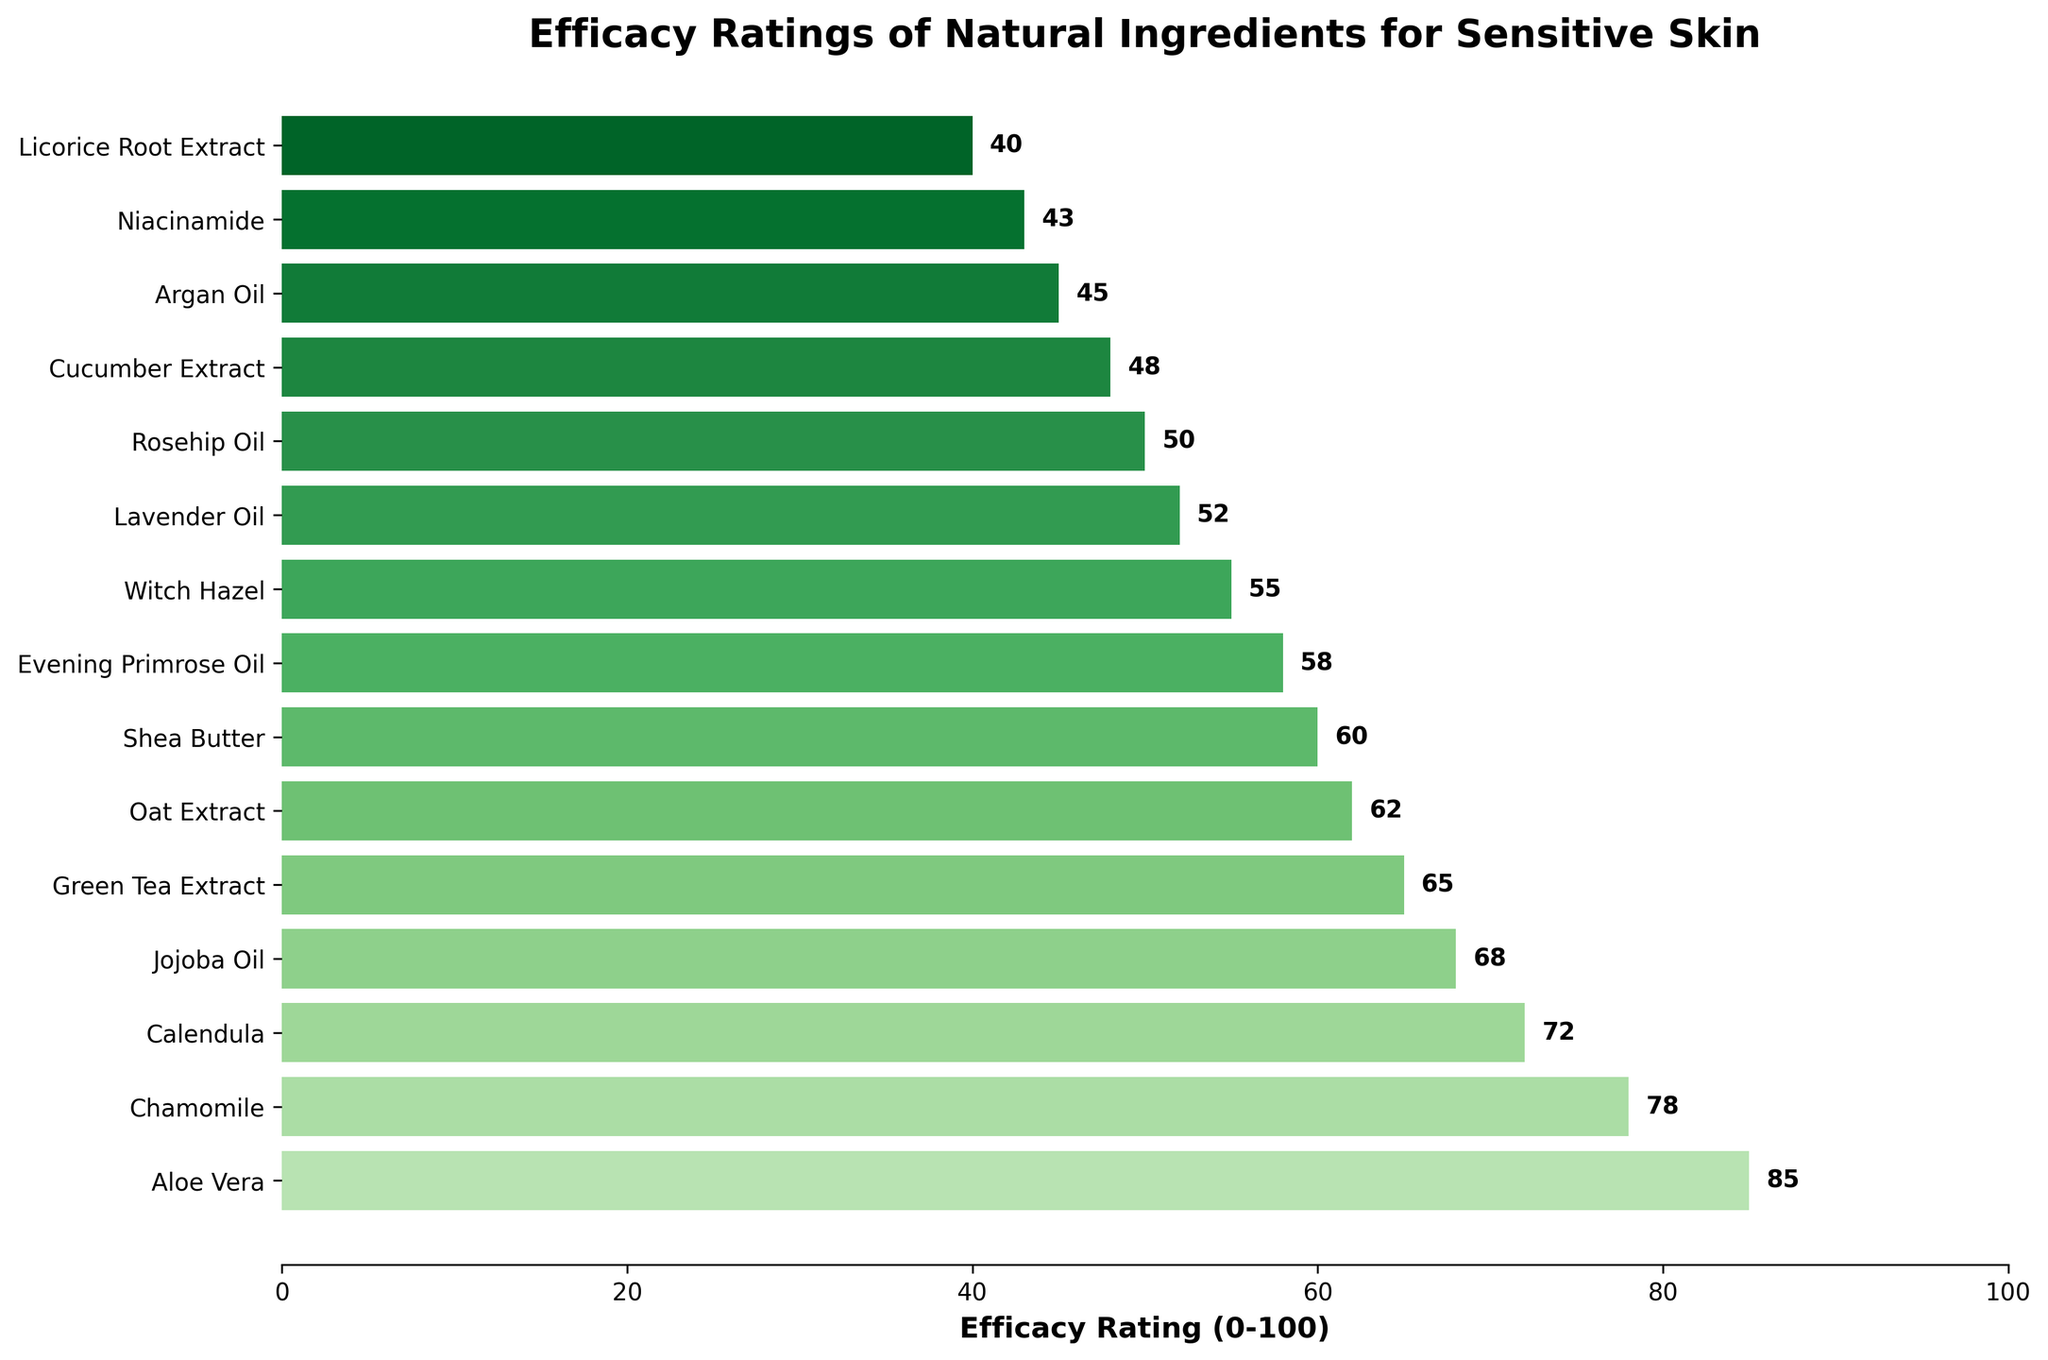Which ingredient has the highest efficacy rating? The bar chart shows that Aloe Vera has the longest bar, representing the highest efficacy rating.
Answer: Aloe Vera Which ingredient has the lowest efficacy rating? The bar chart shows that Licorice Root Extract has the shortest bar, representing the lowest efficacy rating.
Answer: Licorice Root Extract How much higher is the efficacy rating of Aloe Vera compared to Chamomile? Aloe Vera has an efficacy rating of 85, while Chamomile has a rating of 78. The difference is 85 - 78 = 7.
Answer: 7 What is the average efficacy rating of the top three ingredients? The top three ingredients are Aloe Vera (85), Chamomile (78), and Calendula (72). The average is calculated as (85 + 78 + 72) / 3 = 235 / 3 ≈ 78.33.
Answer: 78.33 Compare the efficacy ratings of Jojoba Oil and Evening Primrose Oil. Which one is higher, and by how much? Jojoba Oil has an efficacy rating of 68, while Evening Primrose Oil has a rating of 58. Jojoba Oil's rating is higher by 68 - 58 = 10.
Answer: Jojoba Oil, 10 What are the efficacy ratings of the ingredients with ratings between 50 and 60? The ingredients with ratings between 50 and 60 are Shea Butter (60), Evening Primrose Oil (58), Witch Hazel (55), and Lavender Oil (52).
Answer: Shea Butter: 60, Evening Primrose Oil: 58, Witch Hazel: 55, Lavender Oil: 52 Calculate the total efficacy rating for the ingredients Jojoba Oil, Green Tea Extract, and Oat Extract. Jojoba Oil's rating is 68, Green Tea Extract's rating is 65, and Oat Extract's rating is 62. The total efficacy rating is 68 + 65 + 62 = 195.
Answer: 195 What is the efficacy rating range of the ingredients shown in the chart? The highest rating is 85 (Aloe Vera) and the lowest rating is 40 (Licorice Root Extract). The range is 85 - 40 = 45.
Answer: 45 Which ingredients have efficacy ratings lower than 50? The ingredients with efficacy ratings lower than 50 are Cucumber Extract (48), Argan Oil (45), Niacinamide (43), and Licorice Root Extract (40).
Answer: Cucumber Extract, Argan Oil, Niacinamide, Licorice Root Extract 